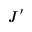<formula> <loc_0><loc_0><loc_500><loc_500>J ^ { \prime }</formula> 